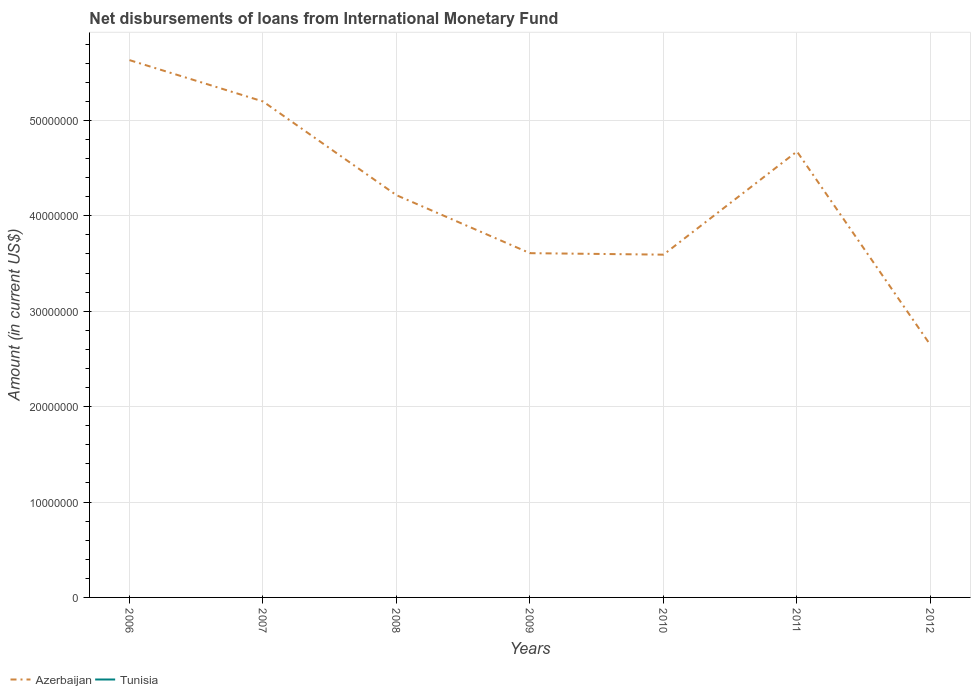Does the line corresponding to Azerbaijan intersect with the line corresponding to Tunisia?
Offer a very short reply. No. Is the number of lines equal to the number of legend labels?
Offer a very short reply. No. Across all years, what is the maximum amount of loans disbursed in Azerbaijan?
Offer a very short reply. 2.65e+07. What is the total amount of loans disbursed in Azerbaijan in the graph?
Provide a succinct answer. 9.82e+06. What is the difference between the highest and the second highest amount of loans disbursed in Azerbaijan?
Provide a short and direct response. 2.99e+07. Is the amount of loans disbursed in Tunisia strictly greater than the amount of loans disbursed in Azerbaijan over the years?
Keep it short and to the point. Yes. How many lines are there?
Your answer should be compact. 1. How many years are there in the graph?
Offer a very short reply. 7. What is the difference between two consecutive major ticks on the Y-axis?
Your answer should be very brief. 1.00e+07. Are the values on the major ticks of Y-axis written in scientific E-notation?
Your answer should be very brief. No. Does the graph contain any zero values?
Ensure brevity in your answer.  Yes. Does the graph contain grids?
Offer a very short reply. Yes. Where does the legend appear in the graph?
Provide a short and direct response. Bottom left. How are the legend labels stacked?
Your answer should be compact. Horizontal. What is the title of the graph?
Your answer should be very brief. Net disbursements of loans from International Monetary Fund. Does "Sweden" appear as one of the legend labels in the graph?
Your response must be concise. No. What is the label or title of the Y-axis?
Make the answer very short. Amount (in current US$). What is the Amount (in current US$) in Azerbaijan in 2006?
Your answer should be compact. 5.63e+07. What is the Amount (in current US$) in Tunisia in 2006?
Offer a terse response. 0. What is the Amount (in current US$) of Azerbaijan in 2007?
Offer a very short reply. 5.20e+07. What is the Amount (in current US$) in Tunisia in 2007?
Your answer should be compact. 0. What is the Amount (in current US$) in Azerbaijan in 2008?
Keep it short and to the point. 4.22e+07. What is the Amount (in current US$) in Azerbaijan in 2009?
Provide a short and direct response. 3.61e+07. What is the Amount (in current US$) of Tunisia in 2009?
Your answer should be compact. 0. What is the Amount (in current US$) of Azerbaijan in 2010?
Give a very brief answer. 3.59e+07. What is the Amount (in current US$) in Azerbaijan in 2011?
Offer a terse response. 4.67e+07. What is the Amount (in current US$) in Tunisia in 2011?
Ensure brevity in your answer.  0. What is the Amount (in current US$) in Azerbaijan in 2012?
Provide a succinct answer. 2.65e+07. Across all years, what is the maximum Amount (in current US$) in Azerbaijan?
Give a very brief answer. 5.63e+07. Across all years, what is the minimum Amount (in current US$) in Azerbaijan?
Provide a short and direct response. 2.65e+07. What is the total Amount (in current US$) of Azerbaijan in the graph?
Your answer should be compact. 2.96e+08. What is the total Amount (in current US$) of Tunisia in the graph?
Provide a succinct answer. 0. What is the difference between the Amount (in current US$) in Azerbaijan in 2006 and that in 2007?
Make the answer very short. 4.33e+06. What is the difference between the Amount (in current US$) in Azerbaijan in 2006 and that in 2008?
Offer a very short reply. 1.42e+07. What is the difference between the Amount (in current US$) of Azerbaijan in 2006 and that in 2009?
Offer a terse response. 2.02e+07. What is the difference between the Amount (in current US$) in Azerbaijan in 2006 and that in 2010?
Your answer should be compact. 2.04e+07. What is the difference between the Amount (in current US$) in Azerbaijan in 2006 and that in 2011?
Make the answer very short. 9.57e+06. What is the difference between the Amount (in current US$) in Azerbaijan in 2006 and that in 2012?
Offer a terse response. 2.99e+07. What is the difference between the Amount (in current US$) of Azerbaijan in 2007 and that in 2008?
Your answer should be compact. 9.82e+06. What is the difference between the Amount (in current US$) of Azerbaijan in 2007 and that in 2009?
Keep it short and to the point. 1.59e+07. What is the difference between the Amount (in current US$) of Azerbaijan in 2007 and that in 2010?
Give a very brief answer. 1.61e+07. What is the difference between the Amount (in current US$) of Azerbaijan in 2007 and that in 2011?
Make the answer very short. 5.24e+06. What is the difference between the Amount (in current US$) of Azerbaijan in 2007 and that in 2012?
Your answer should be compact. 2.55e+07. What is the difference between the Amount (in current US$) in Azerbaijan in 2008 and that in 2009?
Give a very brief answer. 6.08e+06. What is the difference between the Amount (in current US$) of Azerbaijan in 2008 and that in 2010?
Offer a very short reply. 6.23e+06. What is the difference between the Amount (in current US$) in Azerbaijan in 2008 and that in 2011?
Offer a very short reply. -4.58e+06. What is the difference between the Amount (in current US$) of Azerbaijan in 2008 and that in 2012?
Your answer should be very brief. 1.57e+07. What is the difference between the Amount (in current US$) of Azerbaijan in 2009 and that in 2010?
Make the answer very short. 1.56e+05. What is the difference between the Amount (in current US$) in Azerbaijan in 2009 and that in 2011?
Provide a succinct answer. -1.07e+07. What is the difference between the Amount (in current US$) in Azerbaijan in 2009 and that in 2012?
Your answer should be very brief. 9.63e+06. What is the difference between the Amount (in current US$) in Azerbaijan in 2010 and that in 2011?
Provide a short and direct response. -1.08e+07. What is the difference between the Amount (in current US$) in Azerbaijan in 2010 and that in 2012?
Your response must be concise. 9.47e+06. What is the difference between the Amount (in current US$) in Azerbaijan in 2011 and that in 2012?
Offer a terse response. 2.03e+07. What is the average Amount (in current US$) of Azerbaijan per year?
Keep it short and to the point. 4.22e+07. What is the average Amount (in current US$) in Tunisia per year?
Keep it short and to the point. 0. What is the ratio of the Amount (in current US$) of Azerbaijan in 2006 to that in 2008?
Your answer should be compact. 1.34. What is the ratio of the Amount (in current US$) of Azerbaijan in 2006 to that in 2009?
Ensure brevity in your answer.  1.56. What is the ratio of the Amount (in current US$) in Azerbaijan in 2006 to that in 2010?
Make the answer very short. 1.57. What is the ratio of the Amount (in current US$) of Azerbaijan in 2006 to that in 2011?
Give a very brief answer. 1.2. What is the ratio of the Amount (in current US$) of Azerbaijan in 2006 to that in 2012?
Your answer should be compact. 2.13. What is the ratio of the Amount (in current US$) of Azerbaijan in 2007 to that in 2008?
Offer a terse response. 1.23. What is the ratio of the Amount (in current US$) of Azerbaijan in 2007 to that in 2009?
Offer a terse response. 1.44. What is the ratio of the Amount (in current US$) of Azerbaijan in 2007 to that in 2010?
Make the answer very short. 1.45. What is the ratio of the Amount (in current US$) in Azerbaijan in 2007 to that in 2011?
Make the answer very short. 1.11. What is the ratio of the Amount (in current US$) in Azerbaijan in 2007 to that in 2012?
Keep it short and to the point. 1.97. What is the ratio of the Amount (in current US$) of Azerbaijan in 2008 to that in 2009?
Give a very brief answer. 1.17. What is the ratio of the Amount (in current US$) of Azerbaijan in 2008 to that in 2010?
Your response must be concise. 1.17. What is the ratio of the Amount (in current US$) of Azerbaijan in 2008 to that in 2011?
Offer a very short reply. 0.9. What is the ratio of the Amount (in current US$) in Azerbaijan in 2008 to that in 2012?
Your response must be concise. 1.59. What is the ratio of the Amount (in current US$) in Azerbaijan in 2009 to that in 2011?
Give a very brief answer. 0.77. What is the ratio of the Amount (in current US$) of Azerbaijan in 2009 to that in 2012?
Give a very brief answer. 1.36. What is the ratio of the Amount (in current US$) in Azerbaijan in 2010 to that in 2011?
Your response must be concise. 0.77. What is the ratio of the Amount (in current US$) of Azerbaijan in 2010 to that in 2012?
Your answer should be compact. 1.36. What is the ratio of the Amount (in current US$) in Azerbaijan in 2011 to that in 2012?
Your response must be concise. 1.77. What is the difference between the highest and the second highest Amount (in current US$) in Azerbaijan?
Keep it short and to the point. 4.33e+06. What is the difference between the highest and the lowest Amount (in current US$) in Azerbaijan?
Make the answer very short. 2.99e+07. 